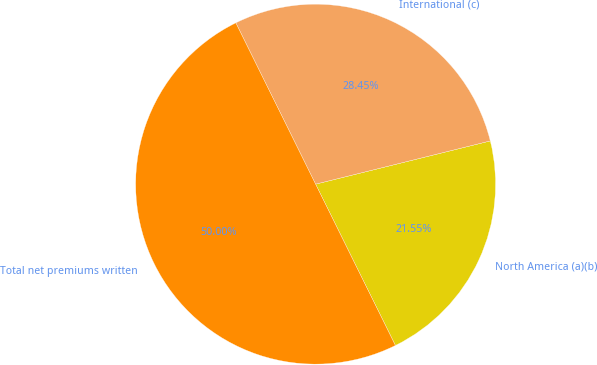<chart> <loc_0><loc_0><loc_500><loc_500><pie_chart><fcel>North America (a)(b)<fcel>International (c)<fcel>Total net premiums written<nl><fcel>21.55%<fcel>28.45%<fcel>50.0%<nl></chart> 